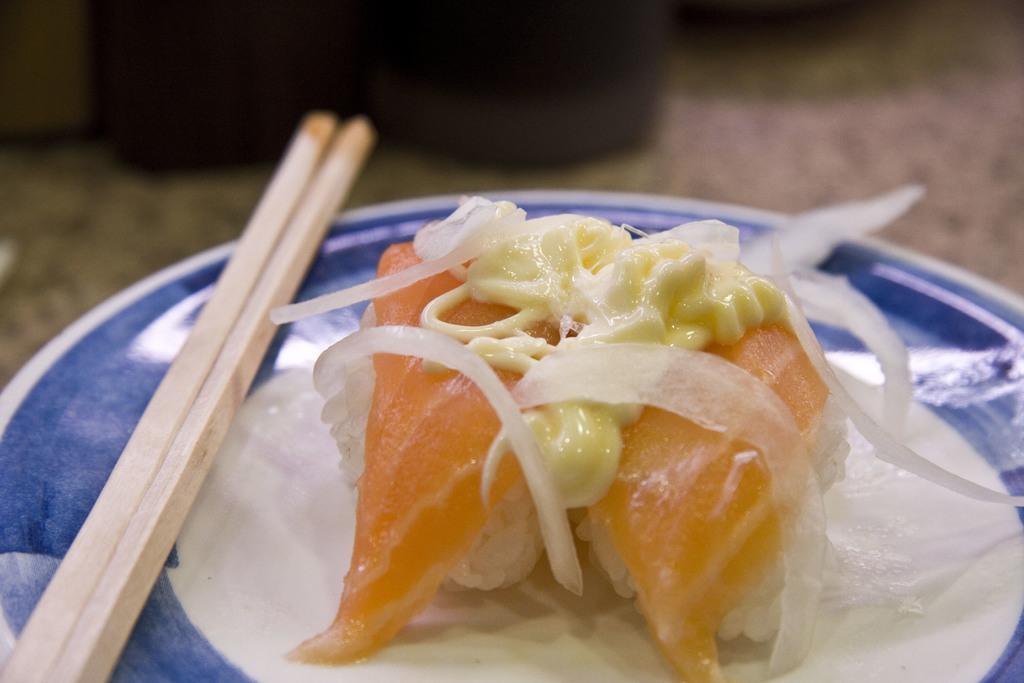Please provide a concise description of this image. There is a food in plate with two chopsticks. 